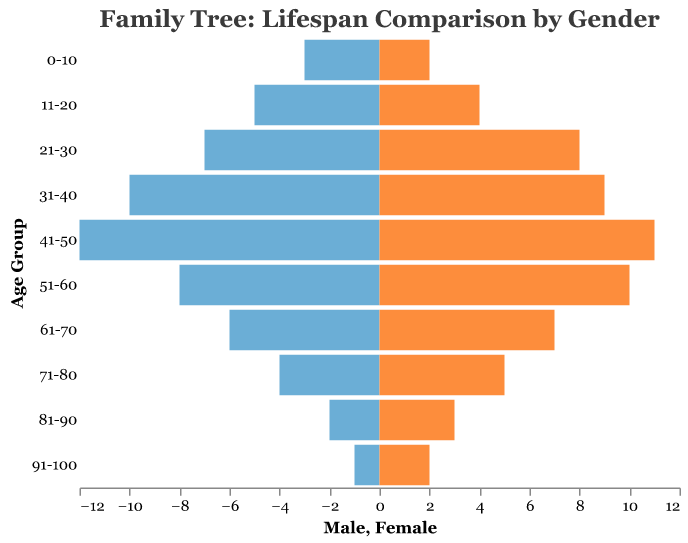what is the title of the figure? The title of the figure is located at the top and summarizes the visualized data. It reads, "Family Tree: Lifespan Comparison by Gender."
Answer: Family Tree: Lifespan Comparison by Gender what age group has the greatest number of male relatives? By examining the bars representing males, the largest bar appears in the "41-50" age group, indicating they have the most male relatives.
Answer: 41-50 how many female relatives are there in the "61-70" age group? By looking at the height of the bar for females in the "61-70" age group, we can see it corresponds to 7 female relatives.
Answer: 7 in which age group do the numbers of male and female relatives differ the most? By comparing the length of the bars for males and females in each age group, the greatest difference appears in the "41-50" age group, where there are 12 males and 11 females, giving a difference of 1.
Answer: 41-50 calculate the total number of male relatives represented in the figure. Add up the counts for all male relatives across all age groups: 3 + 5 + 7 + 10 + 12 + 8 + 6 + 4 + 2 + 1 = 58
Answer: 58 which gender has more relatives in the "51-60" age group? By comparing the bars for "51-60," we see that the females’ bar is longer (10) than the males’ (8).
Answer: Female which age group has equal numbers of male and female relatives? By comparing all the bars, no age group has equal numbers of male and female relatives.
Answer: None what is the median number of male relatives across all age groups? To find the median, list out the number of male relatives: 1, 2, 3, 4, 5, 6, 7, 8, 10, 12. The middle values (5 and 6) average to (5+6)/2 = 5.5
Answer: 5.5 what is the overall trend in the number of relatives as age increases? Observing the bars from youngest to oldest age groups, the number of relatives for both genders generally decreases with increasing age.
Answer: Decreasing identify the age group with the smallest number of female relatives. By observing the smallest bar within the female category, it's the "0-10" age group, which has 2 female relatives.
Answer: 0-10 